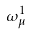Convert formula to latex. <formula><loc_0><loc_0><loc_500><loc_500>\omega _ { \mu } ^ { 1 }</formula> 